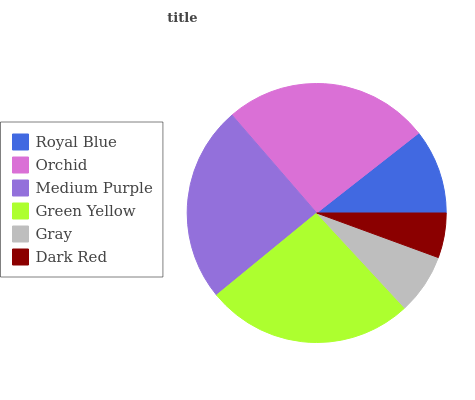Is Dark Red the minimum?
Answer yes or no. Yes. Is Green Yellow the maximum?
Answer yes or no. Yes. Is Orchid the minimum?
Answer yes or no. No. Is Orchid the maximum?
Answer yes or no. No. Is Orchid greater than Royal Blue?
Answer yes or no. Yes. Is Royal Blue less than Orchid?
Answer yes or no. Yes. Is Royal Blue greater than Orchid?
Answer yes or no. No. Is Orchid less than Royal Blue?
Answer yes or no. No. Is Medium Purple the high median?
Answer yes or no. Yes. Is Royal Blue the low median?
Answer yes or no. Yes. Is Gray the high median?
Answer yes or no. No. Is Orchid the low median?
Answer yes or no. No. 